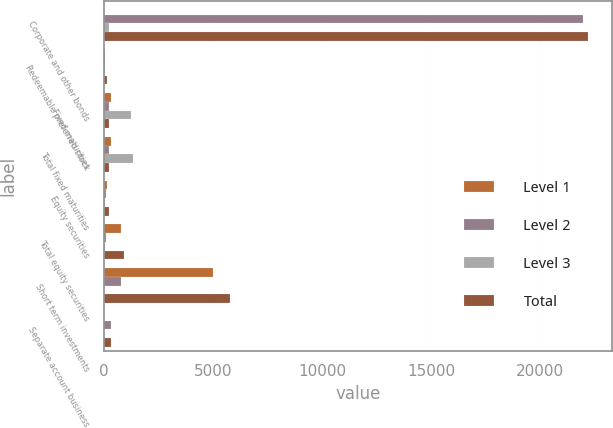<chart> <loc_0><loc_0><loc_500><loc_500><stacked_bar_chart><ecel><fcel>Corporate and other bonds<fcel>Redeemable preferred stock<fcel>Fixed maturities<fcel>Total fixed maturities<fcel>Equity securities<fcel>Total equity securities<fcel>Short term investments<fcel>Separate account business<nl><fcel>Level 1<fcel>6<fcel>40<fcel>344<fcel>344<fcel>117<fcel>759<fcel>4990<fcel>4<nl><fcel>Level 2<fcel>21982<fcel>59<fcel>234<fcel>234<fcel>98<fcel>98<fcel>799<fcel>306<nl><fcel>Level 3<fcel>219<fcel>26<fcel>1251<fcel>1340<fcel>34<fcel>41<fcel>6<fcel>2<nl><fcel>Total<fcel>22207<fcel>125<fcel>234<fcel>234<fcel>249<fcel>898<fcel>5795<fcel>312<nl></chart> 